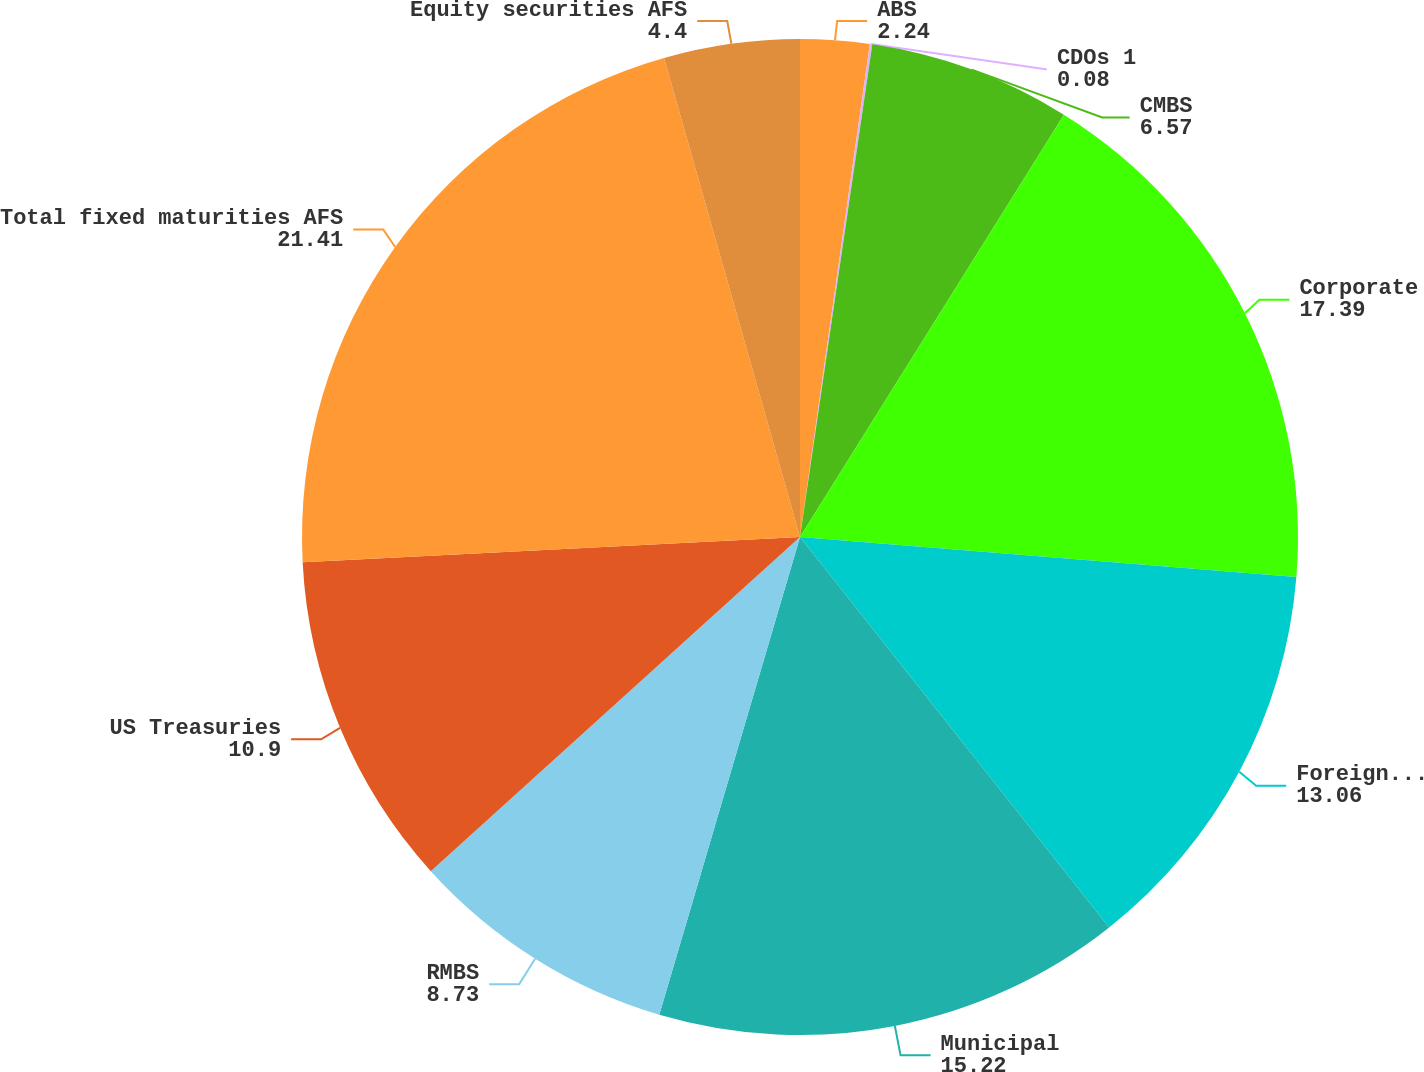<chart> <loc_0><loc_0><loc_500><loc_500><pie_chart><fcel>ABS<fcel>CDOs 1<fcel>CMBS<fcel>Corporate<fcel>Foreign govt/govt agencies<fcel>Municipal<fcel>RMBS<fcel>US Treasuries<fcel>Total fixed maturities AFS<fcel>Equity securities AFS<nl><fcel>2.24%<fcel>0.08%<fcel>6.57%<fcel>17.39%<fcel>13.06%<fcel>15.22%<fcel>8.73%<fcel>10.9%<fcel>21.41%<fcel>4.4%<nl></chart> 